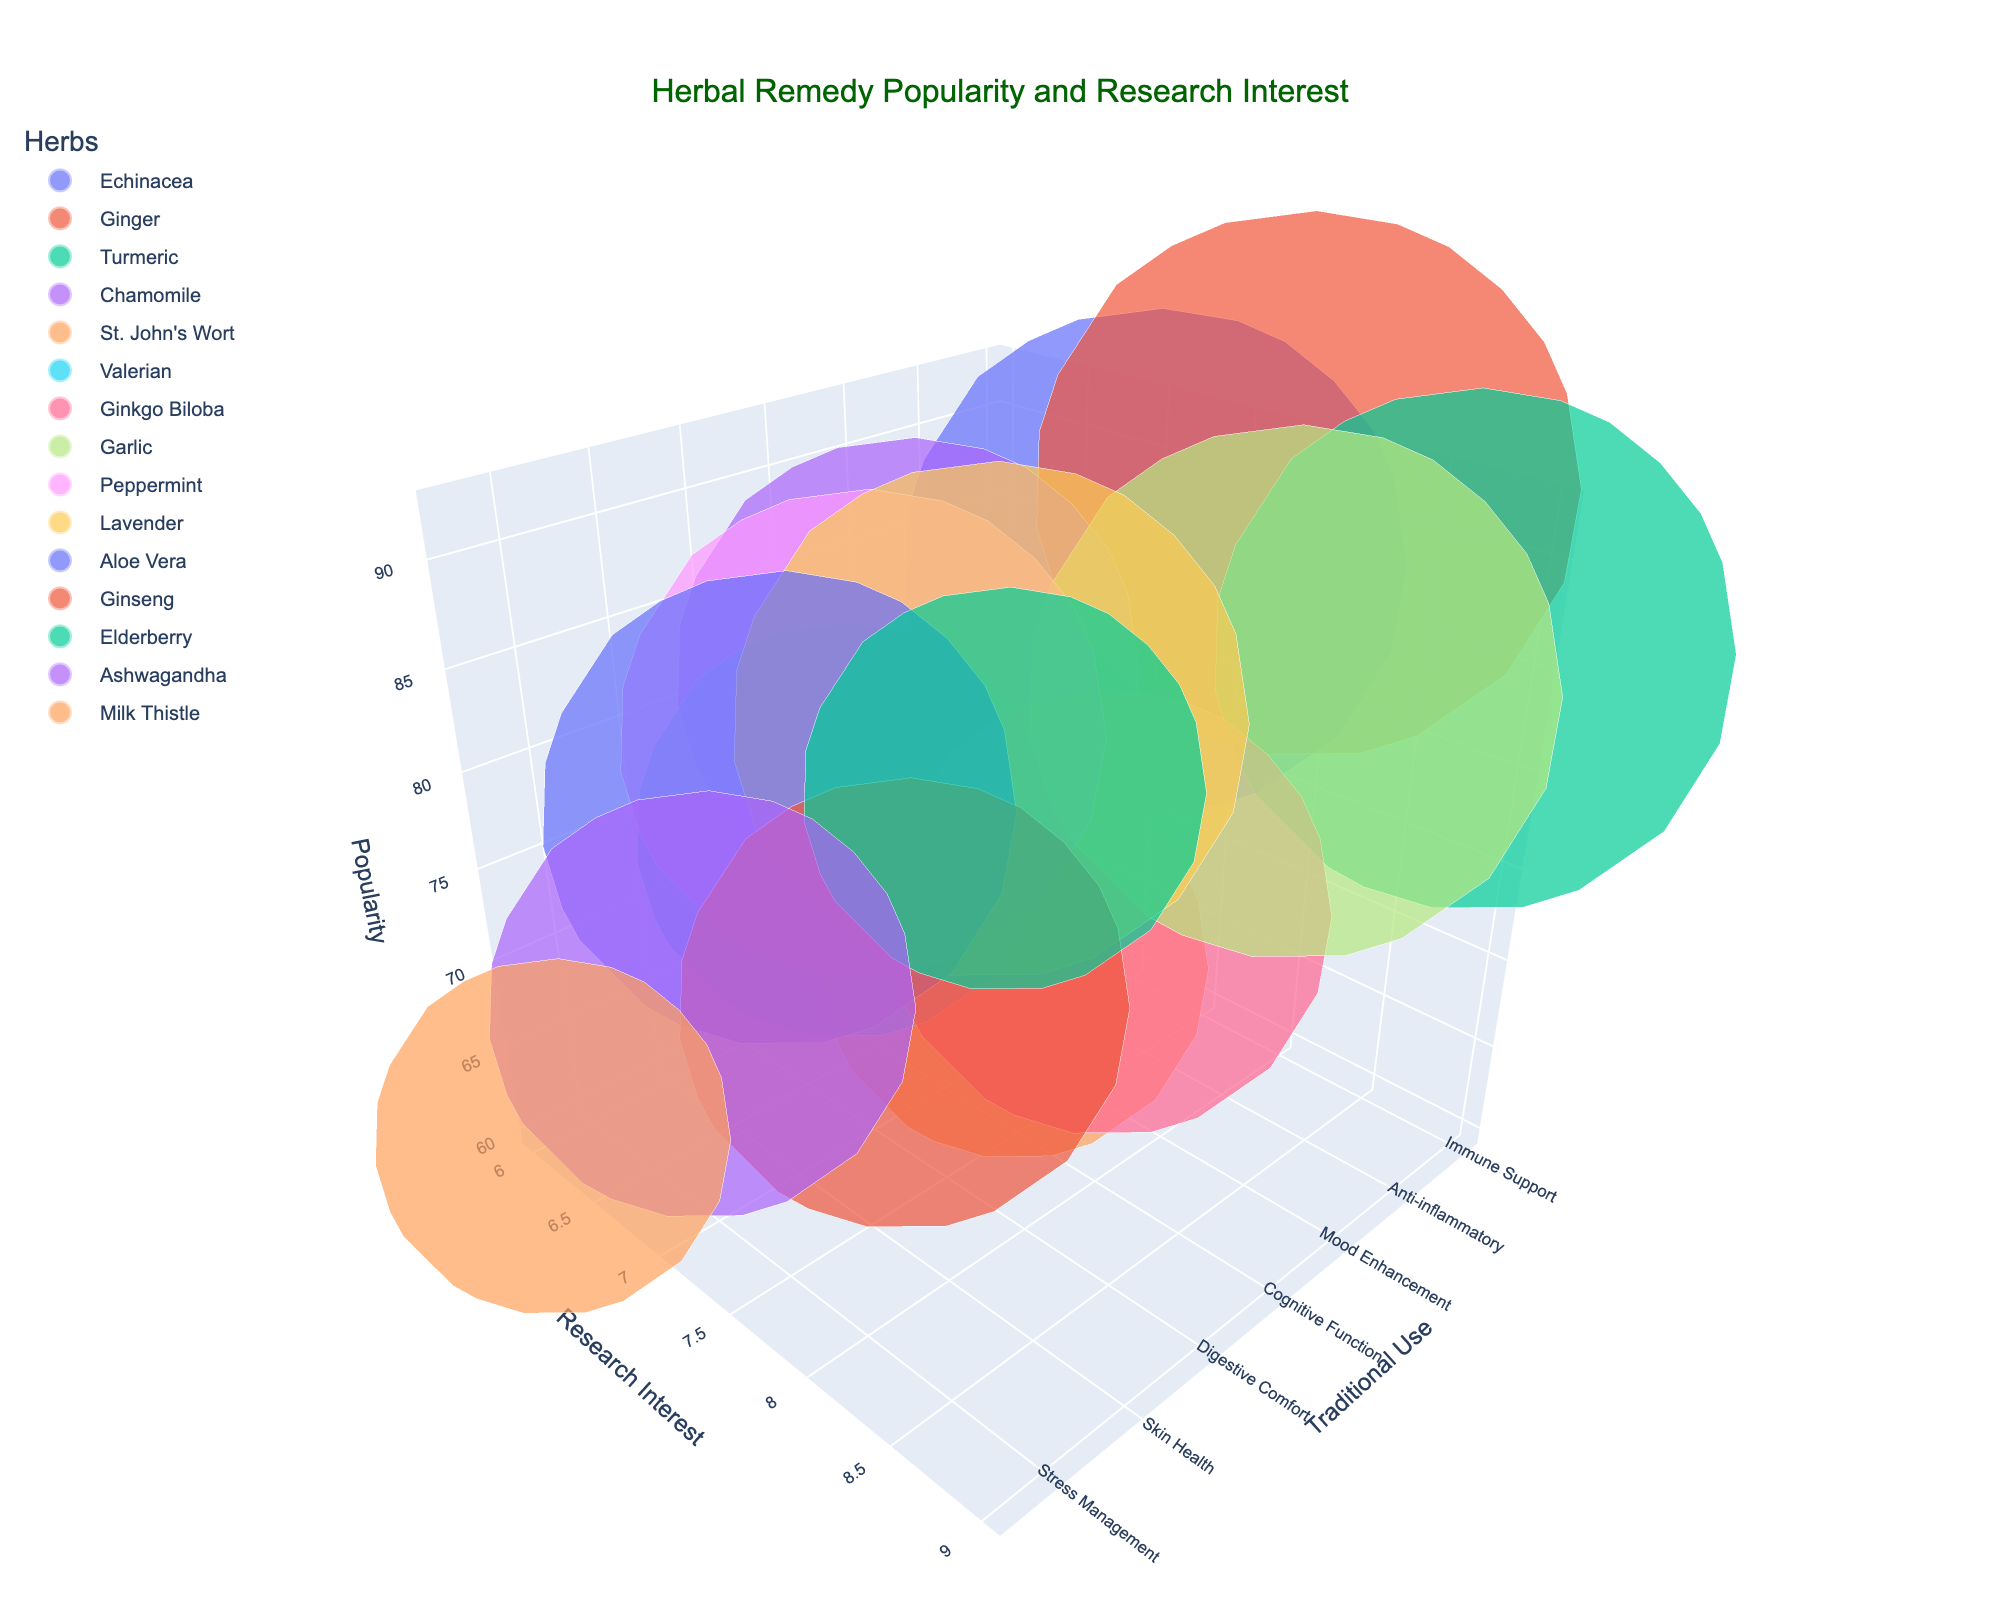How many herbs are displayed in the figure? Count the total number of bubbles (each representing a herb) shown in the 3D bubble chart.
Answer: 15 What is the title of the chart? Identify the text displayed at the top portion of the chart.
Answer: Herbal Remedy Popularity and Research Interest Which herb has the highest research interest? Look at the herb positioned at the highest point on the Scientific Research Interest axis.
Answer: Turmeric and Garlic Which herb is the most popular? Identify the herb with the largest bubble, as bubble size corresponds to popularity.
Answer: Ginger Which herb is categorized under Digestive Aid and how popular is it? Find the herb labeled as Digestive Aid and check its bubble size related to popularity.
Answer: Ginger, 92 How does the popularity of Valerian compare to St. John's Wort? Examine the bubble sizes of both Valerian and St. John's Wort and compare their popularity values.
Answer: Valerian is more popular (70 vs. 65) Which herb is used for Stress Relief, and what is its research interest level? Search for the herb categorized under Stress Relief and look at its position on the Scientific Research Interest axis.
Answer: Lavender, 8 What is the approximate difference in popularity between Lavender and Aloe Vera? Subtract the popularity value of Aloe Vera from that of Lavender.
Answer: 7 (87 - 80) Between the herbs used for Immune Support, which one is more scientifically researched? Compare the Scientific Research Interest axis positions of Echinacea and Elderberry.
Answer: Echinacea Among the herbs for Heart Health, Anti-inflammatory, and Liver Support, which is the least popular? Identify the herbs under these categories (Garlic, Turmeric, Milk Thistle) and compare their popularity values.
Answer: Milk Thistle 